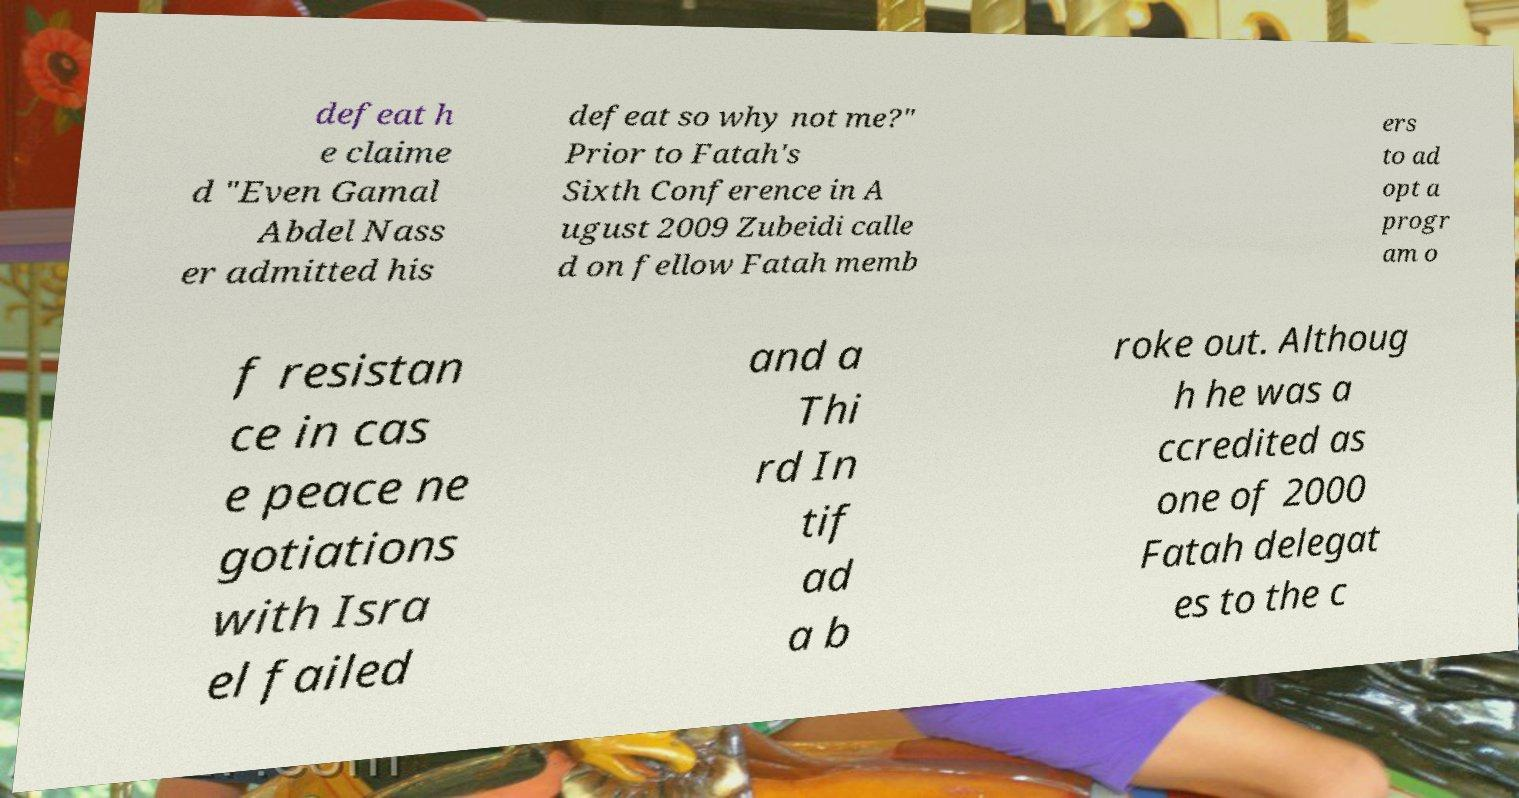There's text embedded in this image that I need extracted. Can you transcribe it verbatim? defeat h e claime d "Even Gamal Abdel Nass er admitted his defeat so why not me?" Prior to Fatah's Sixth Conference in A ugust 2009 Zubeidi calle d on fellow Fatah memb ers to ad opt a progr am o f resistan ce in cas e peace ne gotiations with Isra el failed and a Thi rd In tif ad a b roke out. Althoug h he was a ccredited as one of 2000 Fatah delegat es to the c 